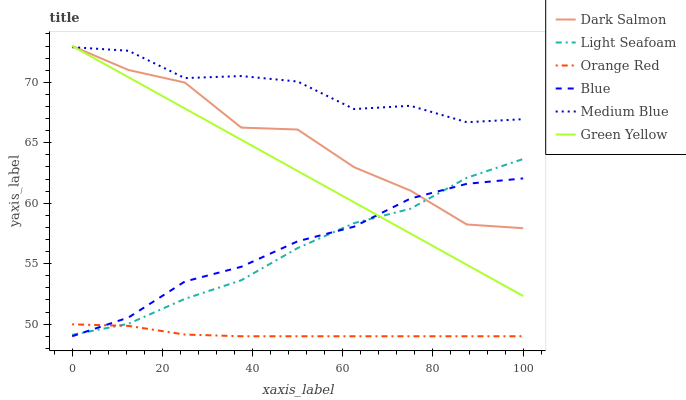Does Orange Red have the minimum area under the curve?
Answer yes or no. Yes. Does Medium Blue have the maximum area under the curve?
Answer yes or no. Yes. Does Light Seafoam have the minimum area under the curve?
Answer yes or no. No. Does Light Seafoam have the maximum area under the curve?
Answer yes or no. No. Is Green Yellow the smoothest?
Answer yes or no. Yes. Is Dark Salmon the roughest?
Answer yes or no. Yes. Is Light Seafoam the smoothest?
Answer yes or no. No. Is Light Seafoam the roughest?
Answer yes or no. No. Does Light Seafoam have the lowest value?
Answer yes or no. No. Does Light Seafoam have the highest value?
Answer yes or no. No. Is Light Seafoam less than Medium Blue?
Answer yes or no. Yes. Is Green Yellow greater than Orange Red?
Answer yes or no. Yes. Does Light Seafoam intersect Medium Blue?
Answer yes or no. No. 